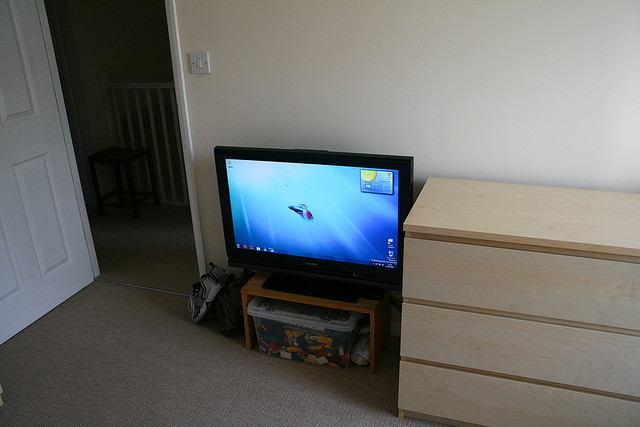What is the make and model of the television shown? The television visible in the image is a Samsung flat screen model, estimated to be a mid-2000s LCD based on its design characteristics such as the thicker bezel and the overall size compared to modern models. 